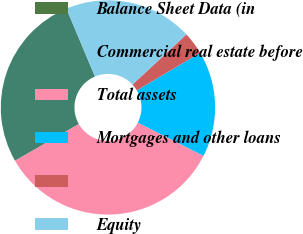Convert chart. <chart><loc_0><loc_0><loc_500><loc_500><pie_chart><fcel>Balance Sheet Data (in<fcel>Commercial real estate before<fcel>Total assets<fcel>Mortgages and other loans<fcel>Unnamed: 4<fcel>Equity<nl><fcel>0.01%<fcel>26.96%<fcel>34.24%<fcel>15.97%<fcel>3.43%<fcel>19.4%<nl></chart> 